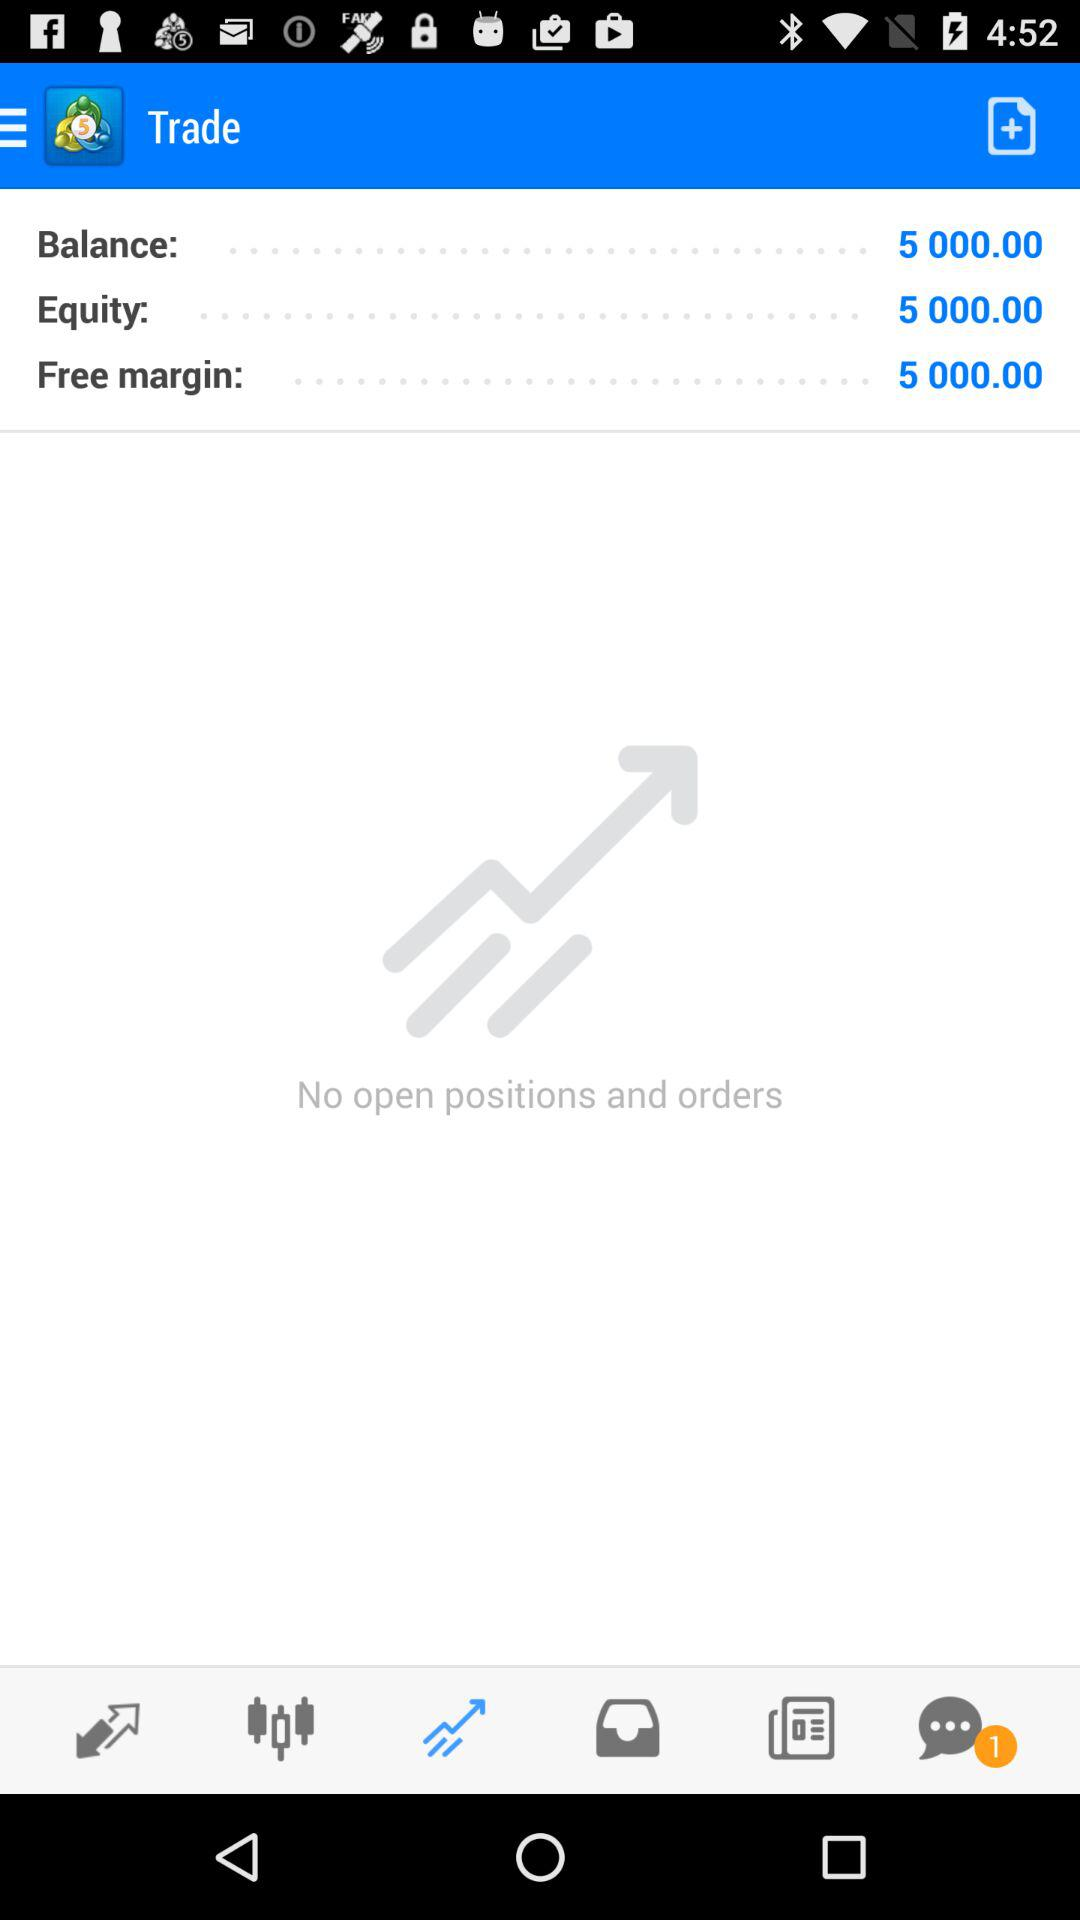Which tab is selected? The selected tab is "Trade". 